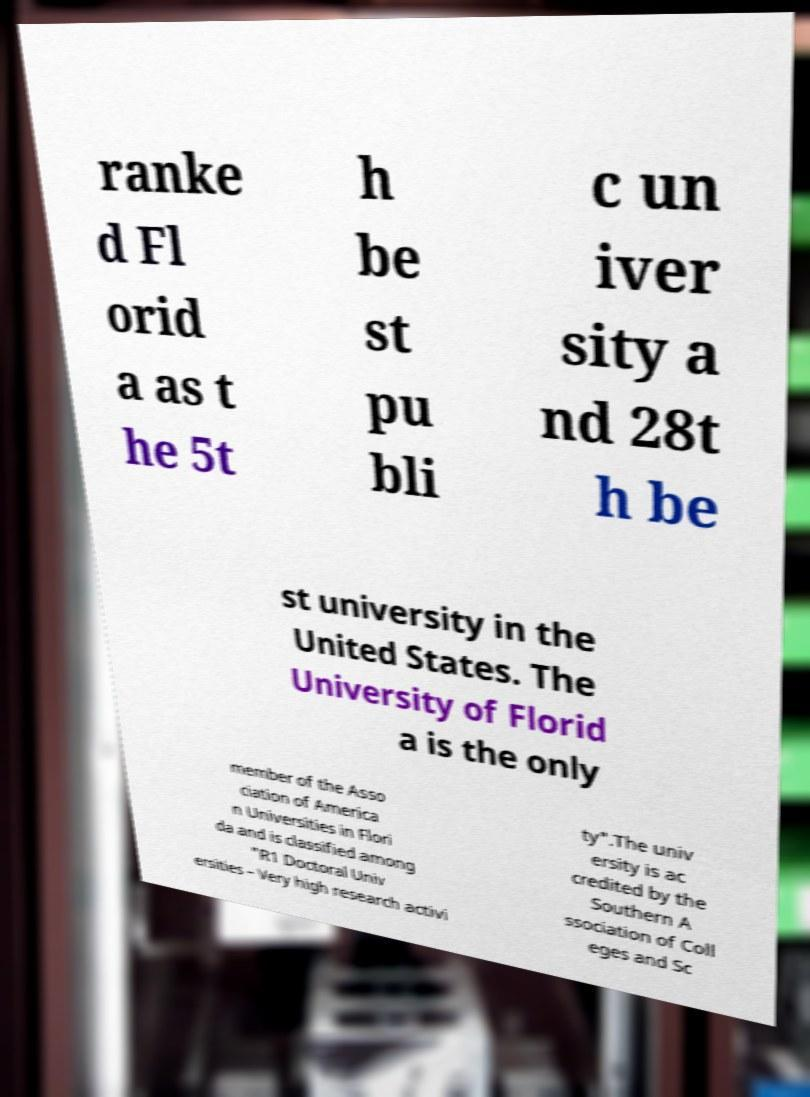Could you extract and type out the text from this image? ranke d Fl orid a as t he 5t h be st pu bli c un iver sity a nd 28t h be st university in the United States. The University of Florid a is the only member of the Asso ciation of America n Universities in Flori da and is classified among "R1 Doctoral Univ ersities – Very high research activi ty".The univ ersity is ac credited by the Southern A ssociation of Coll eges and Sc 